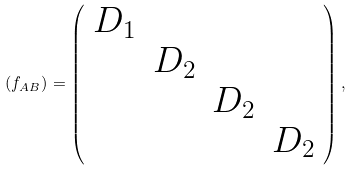Convert formula to latex. <formula><loc_0><loc_0><loc_500><loc_500>( f _ { A B } ) = \left ( \begin{array} { c c c c } D _ { 1 } & & & \\ & D _ { 2 } & & \\ & & D _ { 2 } & \\ & & & D _ { 2 } \\ \end{array} \right ) ,</formula> 